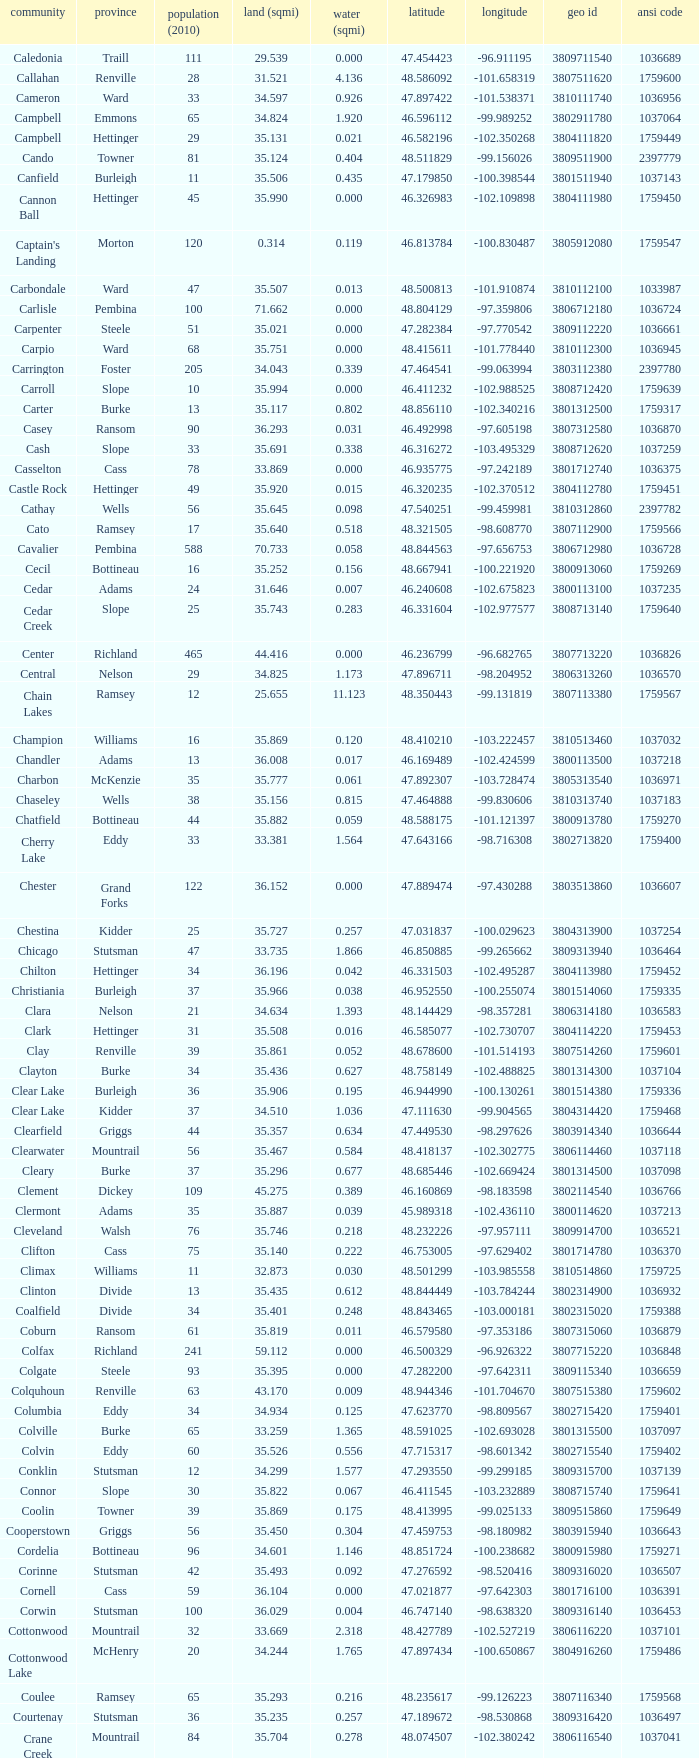075823? -98.857272. 